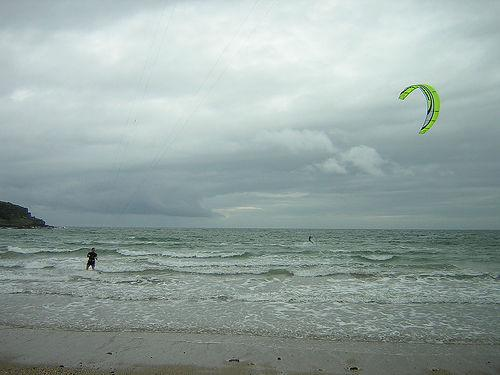Question: where is the picture taken at?
Choices:
A. Beach.
B. Park.
C. Zoo.
D. Airport.
Answer with the letter. Answer: A Question: why is the sail in the sky?
Choices:
A. It's falling.
B. Someone threw it.
C. Hanging out a window.
D. Wind lifts it up.
Answer with the letter. Answer: D Question: how is the man being moved?
Choices:
A. Bus.
B. Car.
C. Train.
D. The sail.
Answer with the letter. Answer: D Question: what are the men in?
Choices:
A. Water.
B. Grass.
C. Quicksand.
D. Mud.
Answer with the letter. Answer: A Question: what is wavy?
Choices:
A. Waves.
B. Table cloth.
C. Tv signal.
D. Chips.
Answer with the letter. Answer: A 